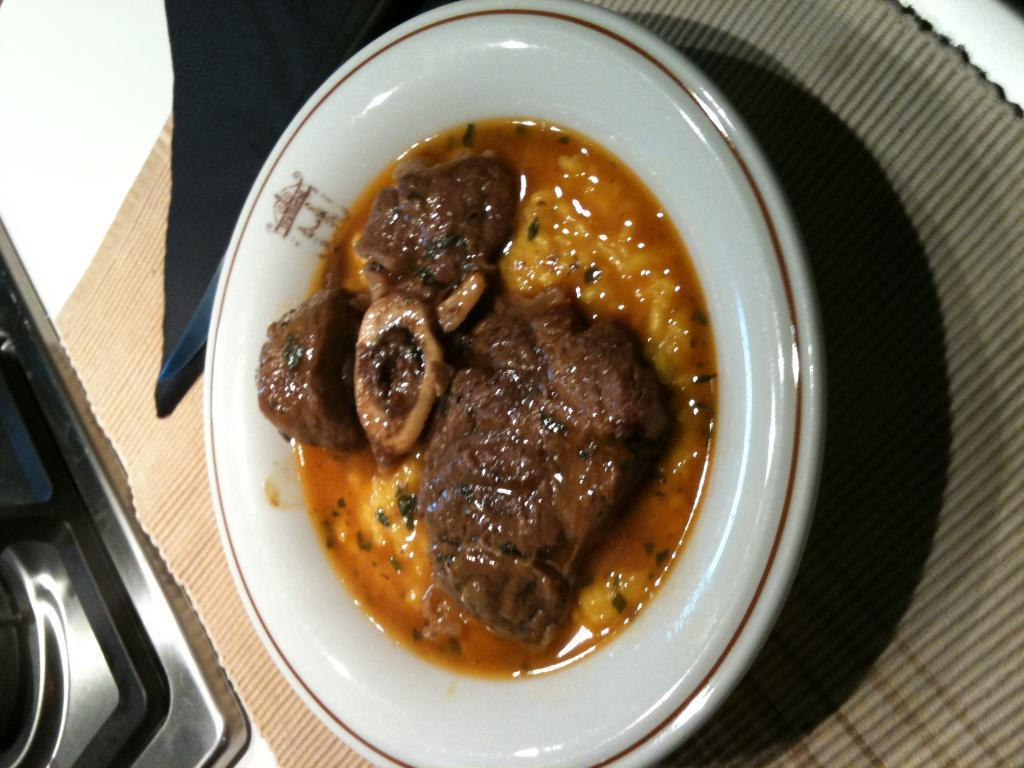What is covering the table in the image? There is a table covered with a cloth in the image. What can be seen on top of the tablecloth? There is a plate with food items on the table. What is located on the left side of the table? There is a metal object on the left side of the table. Can you describe the unspecified object in the image? Unfortunately, the provided facts do not specify the nature of the unspecified object. How does the baseball player pull the key from the table in the image? There is no baseball player or key present in the image. What type of baseball game is being played in the image? There is no baseball game or any reference to baseball in the image. 